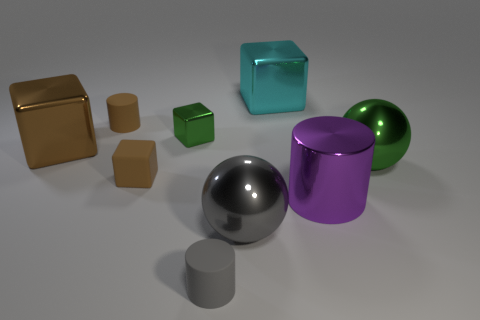There is a big object that is the same shape as the small gray rubber object; what is it made of?
Your response must be concise. Metal. What is the color of the small shiny thing?
Keep it short and to the point. Green. What number of things are cyan metal cubes or large things?
Offer a very short reply. 5. What shape is the brown thing that is to the right of the rubber cylinder that is behind the big purple shiny thing?
Offer a terse response. Cube. How many other objects are there of the same material as the big cyan block?
Make the answer very short. 5. Do the tiny green thing and the green object on the right side of the gray cylinder have the same material?
Your answer should be compact. Yes. How many things are either tiny cylinders behind the big purple metallic object or tiny matte objects behind the big green metallic object?
Ensure brevity in your answer.  1. What number of other things are there of the same color as the tiny shiny cube?
Your answer should be compact. 1. Are there more metallic spheres that are on the right side of the rubber cube than large cylinders behind the big cylinder?
Give a very brief answer. Yes. How many cylinders are large yellow metal objects or large things?
Offer a terse response. 1. 